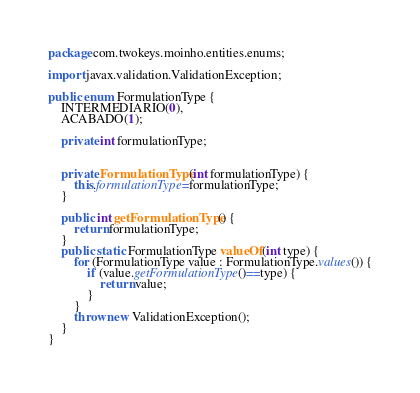Convert code to text. <code><loc_0><loc_0><loc_500><loc_500><_Java_>package com.twokeys.moinho.entities.enums;

import javax.validation.ValidationException;

public enum FormulationType {
	INTERMEDIARIO(0),
	ACABADO(1);
	
	private int formulationType;
	

	private FormulationType(int formulationType) {
		this.formulationType=formulationType;
	}
	
	public int getFormulationType() {
		return formulationType;
	}
	public static FormulationType valueOf(int type) {
		for (FormulationType value : FormulationType.values()) {
			if (value.getFormulationType()==type) {
				return value;
			}
		}
		throw new ValidationException();
	}
}
</code> 